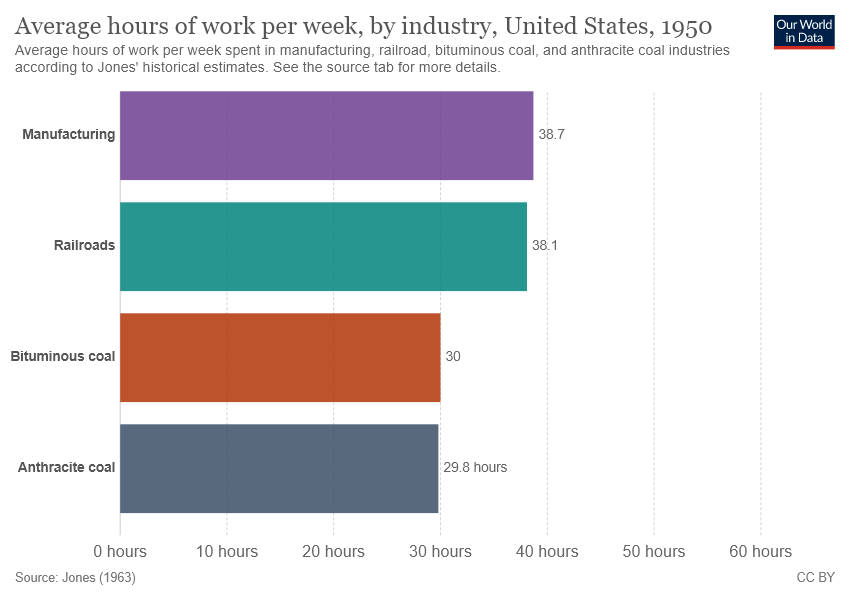List a handful of essential elements in this visual. The total average value of manufacturing and railroads is more than 38. This is correct. According to the information provided, two industries have a value greater than 30: manufacturing and railroads. 